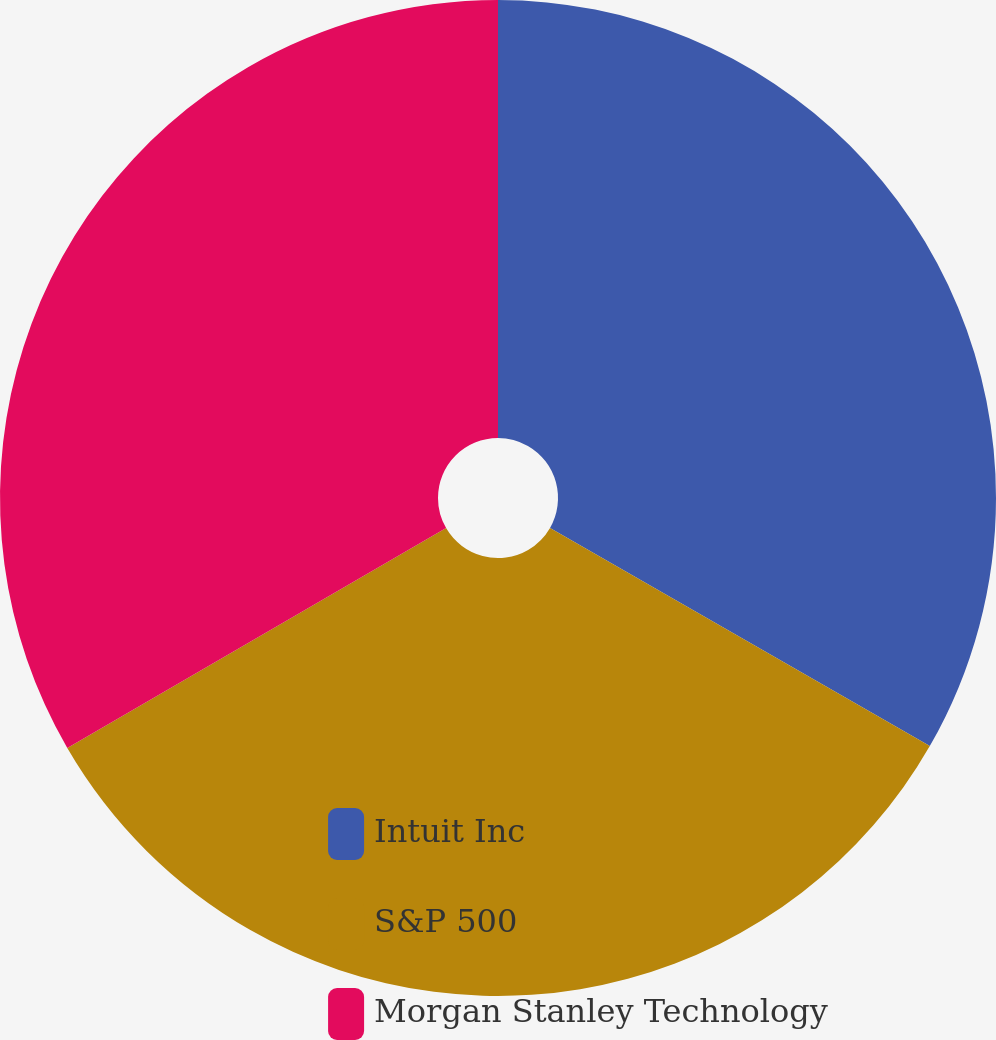Convert chart to OTSL. <chart><loc_0><loc_0><loc_500><loc_500><pie_chart><fcel>Intuit Inc<fcel>S&P 500<fcel>Morgan Stanley Technology<nl><fcel>33.3%<fcel>33.33%<fcel>33.37%<nl></chart> 